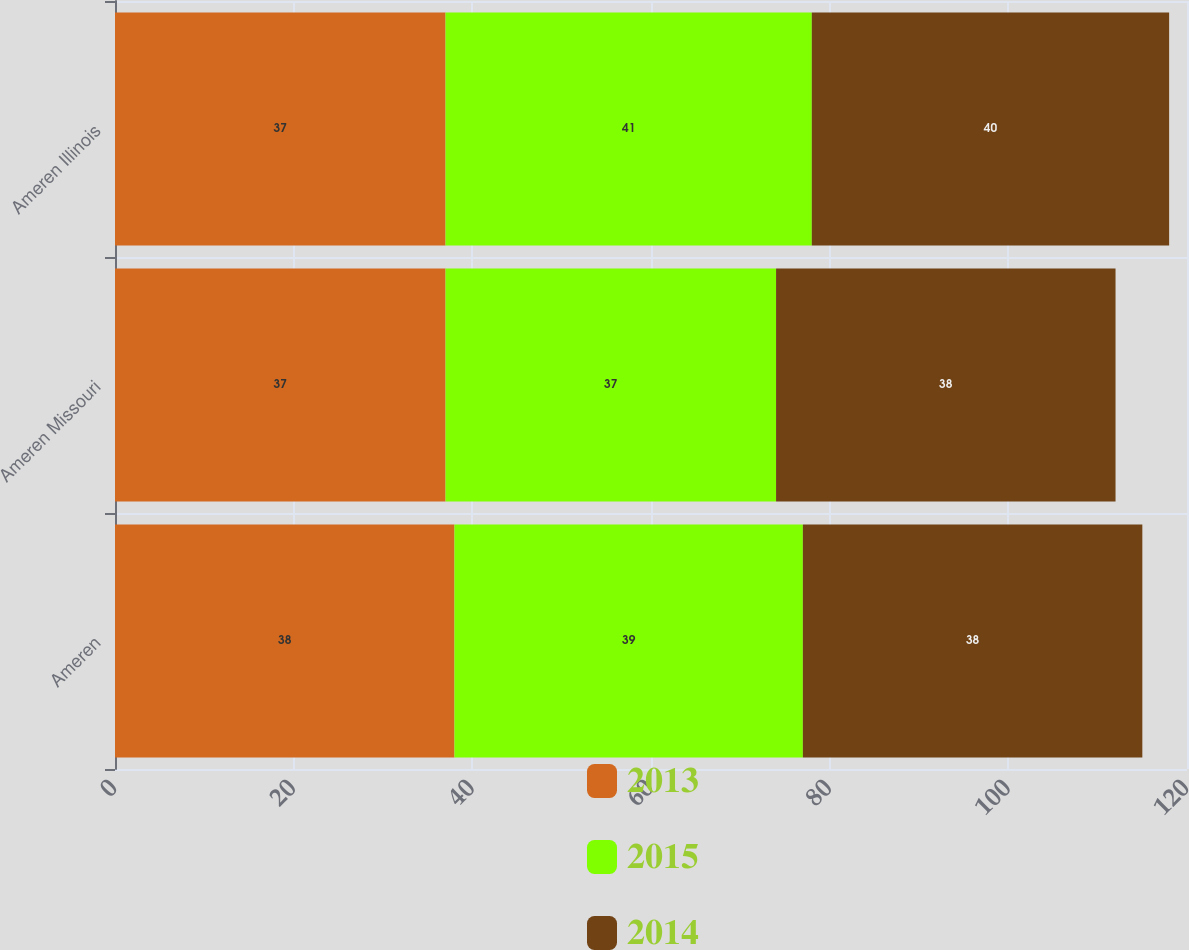<chart> <loc_0><loc_0><loc_500><loc_500><stacked_bar_chart><ecel><fcel>Ameren<fcel>Ameren Missouri<fcel>Ameren Illinois<nl><fcel>2013<fcel>38<fcel>37<fcel>37<nl><fcel>2015<fcel>39<fcel>37<fcel>41<nl><fcel>2014<fcel>38<fcel>38<fcel>40<nl></chart> 